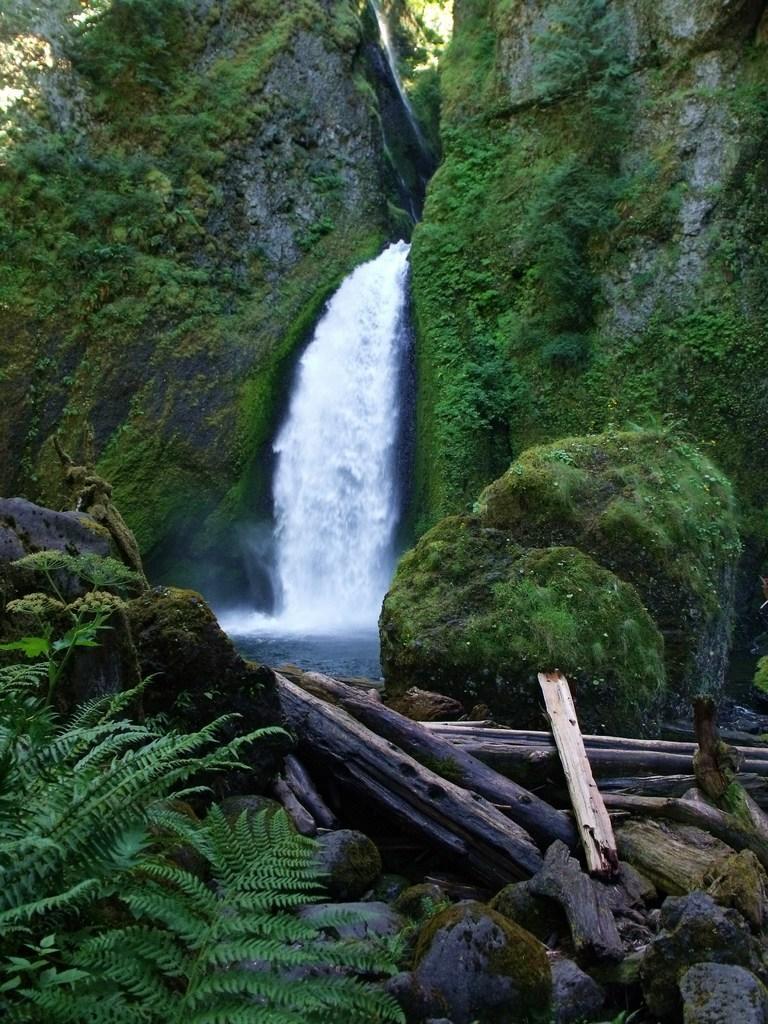How would you summarize this image in a sentence or two? This image consists of mountains. In the middle, there is a waterfall. And we can see the wooden sticks. At the bottom, there are rocks and plants. And we can see the grass on the rocks. 